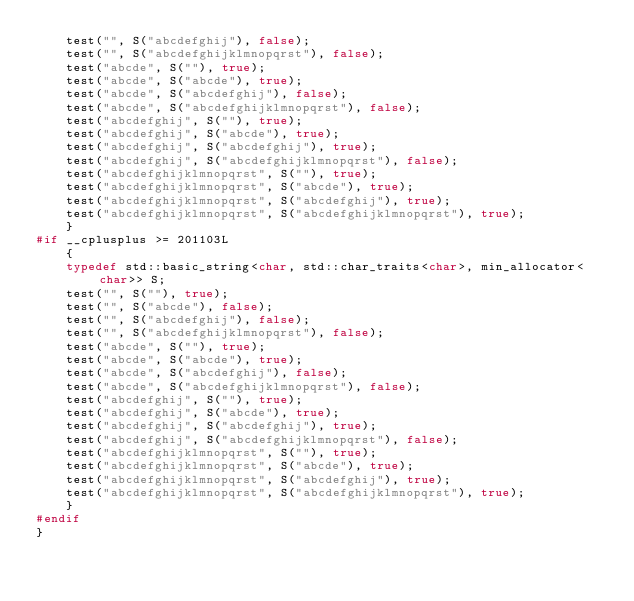<code> <loc_0><loc_0><loc_500><loc_500><_C++_>    test("", S("abcdefghij"), false);
    test("", S("abcdefghijklmnopqrst"), false);
    test("abcde", S(""), true);
    test("abcde", S("abcde"), true);
    test("abcde", S("abcdefghij"), false);
    test("abcde", S("abcdefghijklmnopqrst"), false);
    test("abcdefghij", S(""), true);
    test("abcdefghij", S("abcde"), true);
    test("abcdefghij", S("abcdefghij"), true);
    test("abcdefghij", S("abcdefghijklmnopqrst"), false);
    test("abcdefghijklmnopqrst", S(""), true);
    test("abcdefghijklmnopqrst", S("abcde"), true);
    test("abcdefghijklmnopqrst", S("abcdefghij"), true);
    test("abcdefghijklmnopqrst", S("abcdefghijklmnopqrst"), true);
    }
#if __cplusplus >= 201103L
    {
    typedef std::basic_string<char, std::char_traits<char>, min_allocator<char>> S;
    test("", S(""), true);
    test("", S("abcde"), false);
    test("", S("abcdefghij"), false);
    test("", S("abcdefghijklmnopqrst"), false);
    test("abcde", S(""), true);
    test("abcde", S("abcde"), true);
    test("abcde", S("abcdefghij"), false);
    test("abcde", S("abcdefghijklmnopqrst"), false);
    test("abcdefghij", S(""), true);
    test("abcdefghij", S("abcde"), true);
    test("abcdefghij", S("abcdefghij"), true);
    test("abcdefghij", S("abcdefghijklmnopqrst"), false);
    test("abcdefghijklmnopqrst", S(""), true);
    test("abcdefghijklmnopqrst", S("abcde"), true);
    test("abcdefghijklmnopqrst", S("abcdefghij"), true);
    test("abcdefghijklmnopqrst", S("abcdefghijklmnopqrst"), true);
    }
#endif
}
</code> 